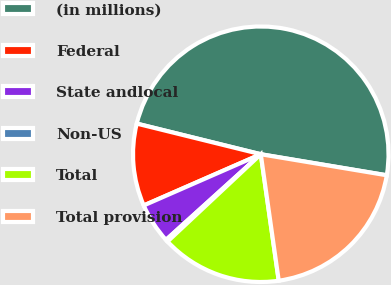Convert chart. <chart><loc_0><loc_0><loc_500><loc_500><pie_chart><fcel>(in millions)<fcel>Federal<fcel>State andlocal<fcel>Non-US<fcel>Total<fcel>Total provision<nl><fcel>48.78%<fcel>10.42%<fcel>5.13%<fcel>0.28%<fcel>15.27%<fcel>20.12%<nl></chart> 